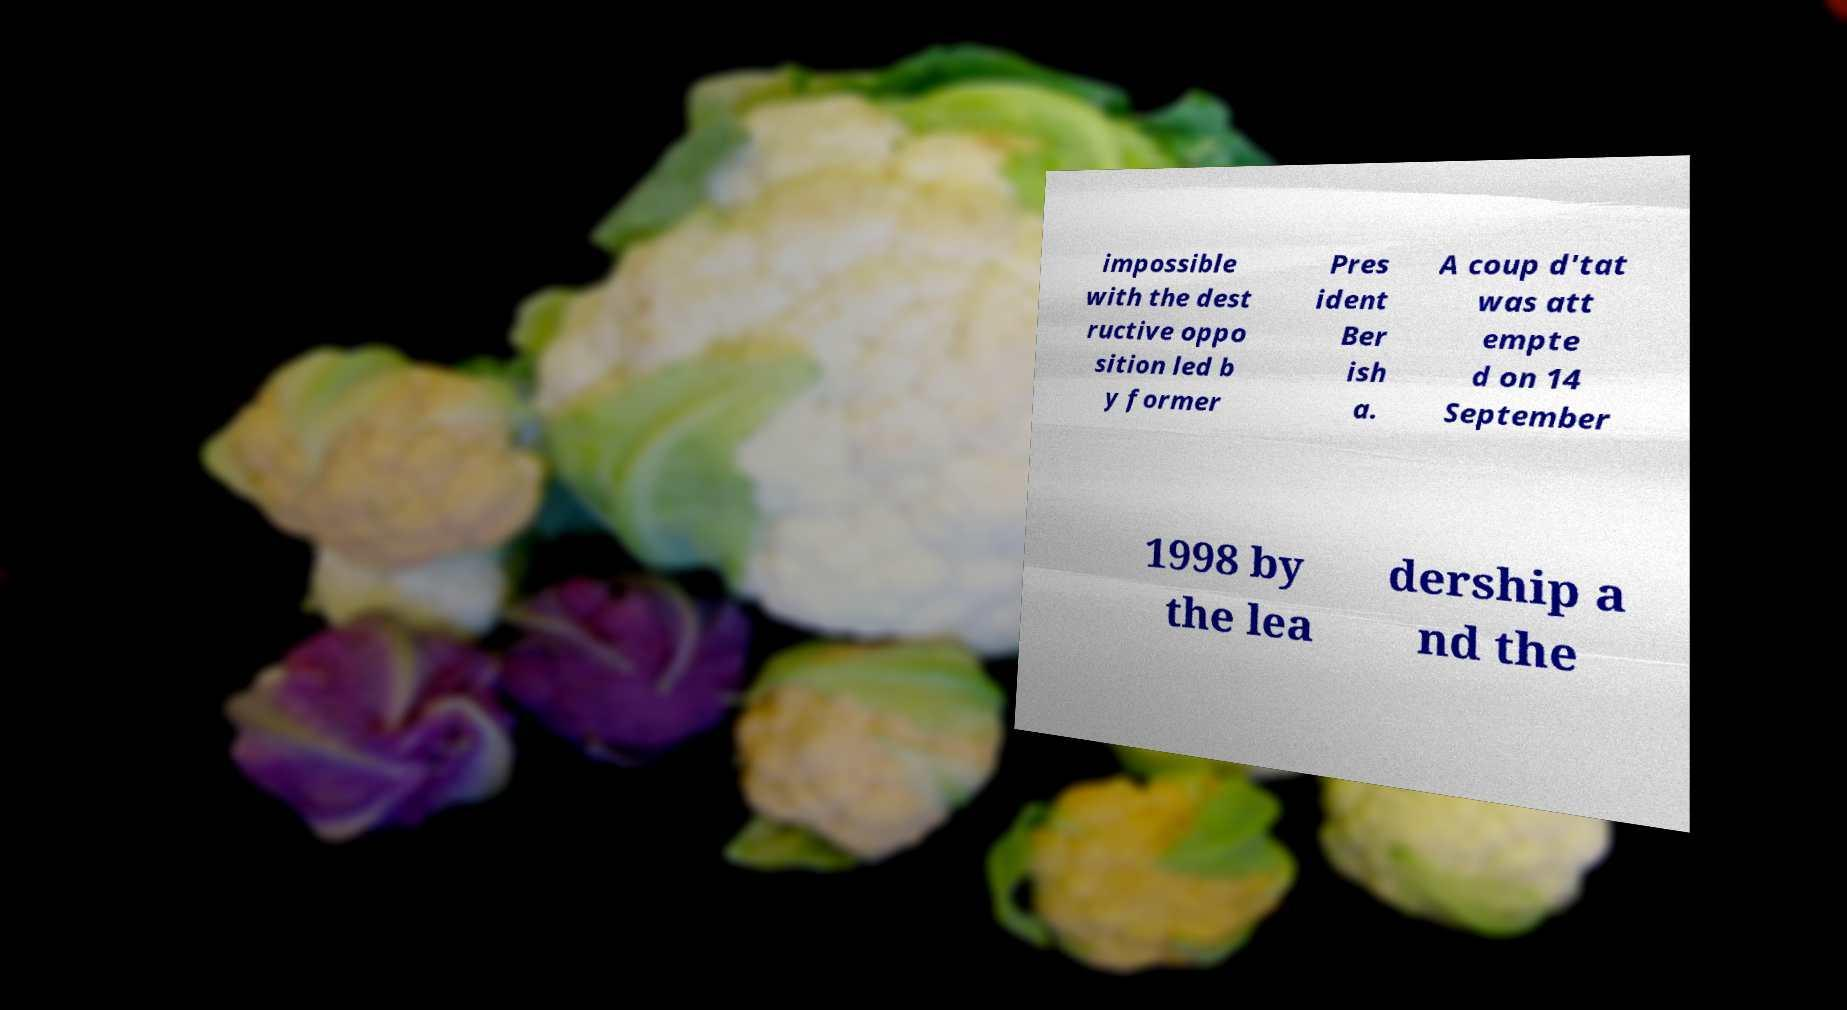Please identify and transcribe the text found in this image. impossible with the dest ructive oppo sition led b y former Pres ident Ber ish a. A coup d'tat was att empte d on 14 September 1998 by the lea dership a nd the 